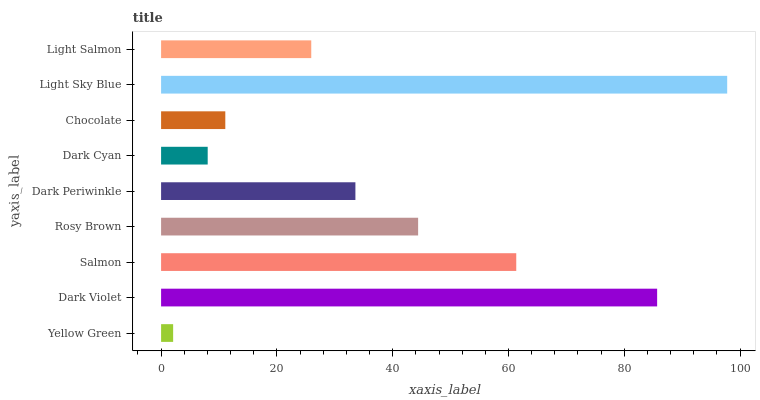Is Yellow Green the minimum?
Answer yes or no. Yes. Is Light Sky Blue the maximum?
Answer yes or no. Yes. Is Dark Violet the minimum?
Answer yes or no. No. Is Dark Violet the maximum?
Answer yes or no. No. Is Dark Violet greater than Yellow Green?
Answer yes or no. Yes. Is Yellow Green less than Dark Violet?
Answer yes or no. Yes. Is Yellow Green greater than Dark Violet?
Answer yes or no. No. Is Dark Violet less than Yellow Green?
Answer yes or no. No. Is Dark Periwinkle the high median?
Answer yes or no. Yes. Is Dark Periwinkle the low median?
Answer yes or no. Yes. Is Yellow Green the high median?
Answer yes or no. No. Is Light Salmon the low median?
Answer yes or no. No. 